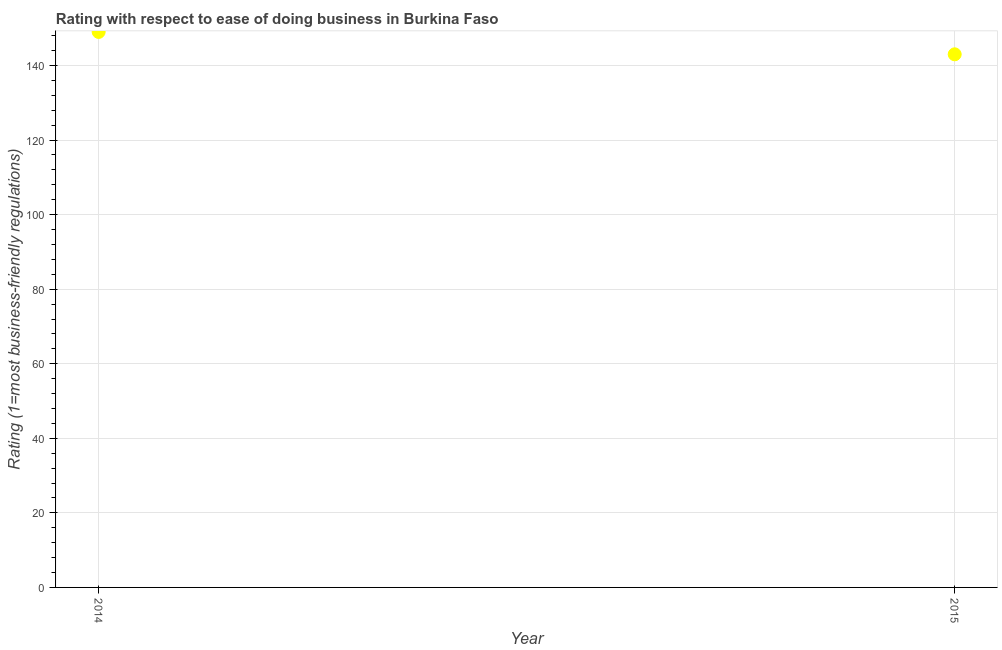What is the ease of doing business index in 2015?
Provide a short and direct response. 143. Across all years, what is the maximum ease of doing business index?
Make the answer very short. 149. Across all years, what is the minimum ease of doing business index?
Offer a very short reply. 143. In which year was the ease of doing business index maximum?
Your response must be concise. 2014. In which year was the ease of doing business index minimum?
Provide a short and direct response. 2015. What is the sum of the ease of doing business index?
Give a very brief answer. 292. What is the average ease of doing business index per year?
Your answer should be very brief. 146. What is the median ease of doing business index?
Your response must be concise. 146. In how many years, is the ease of doing business index greater than 140 ?
Ensure brevity in your answer.  2. What is the ratio of the ease of doing business index in 2014 to that in 2015?
Your response must be concise. 1.04. In how many years, is the ease of doing business index greater than the average ease of doing business index taken over all years?
Provide a short and direct response. 1. What is the title of the graph?
Provide a short and direct response. Rating with respect to ease of doing business in Burkina Faso. What is the label or title of the X-axis?
Ensure brevity in your answer.  Year. What is the label or title of the Y-axis?
Your response must be concise. Rating (1=most business-friendly regulations). What is the Rating (1=most business-friendly regulations) in 2014?
Ensure brevity in your answer.  149. What is the Rating (1=most business-friendly regulations) in 2015?
Make the answer very short. 143. What is the difference between the Rating (1=most business-friendly regulations) in 2014 and 2015?
Offer a terse response. 6. What is the ratio of the Rating (1=most business-friendly regulations) in 2014 to that in 2015?
Ensure brevity in your answer.  1.04. 